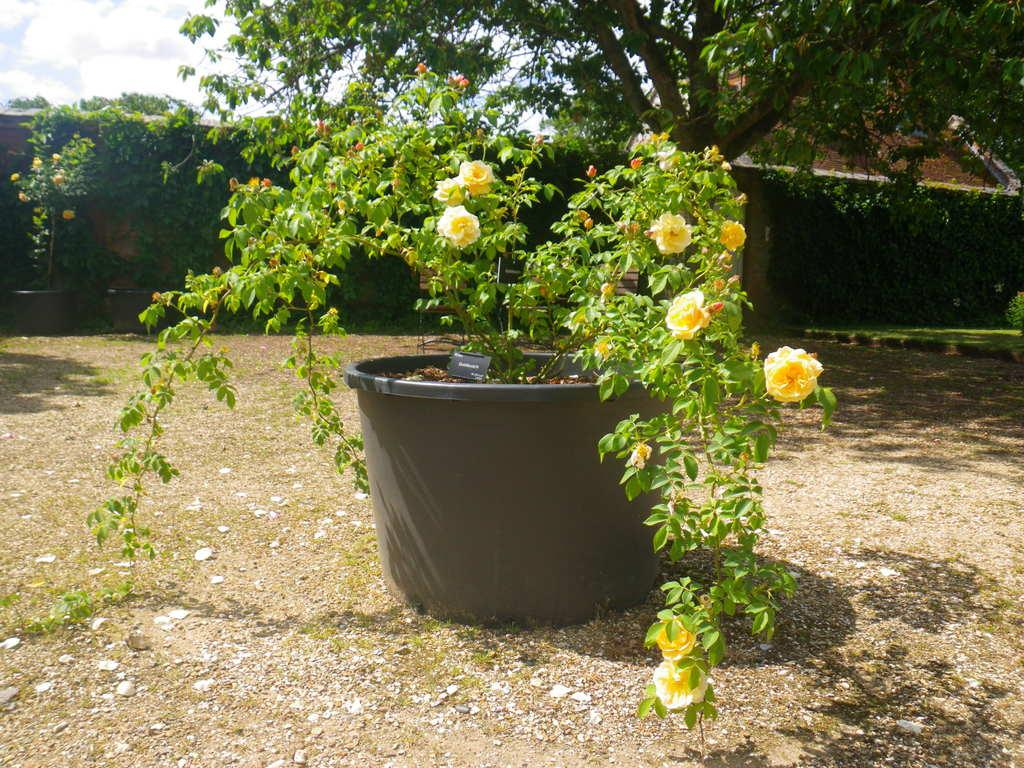What is located in the foreground of the image? There is a flower pot in the foreground of the image. What is inside the flower pot? There is a plant in the flower pot. What type of flowers can be seen in the image? There are rose flowers in the image. What type of vegetation is at the bottom of the image? There is grass at the bottom of the image. What structures can be seen in the background of the image? There are houses and a wall in the background of the image. What type of straw is used to support the nerve in the image? There is no straw or nerve present in the image; it features a flower pot, a plant, rose flowers, grass, houses, and a wall. 